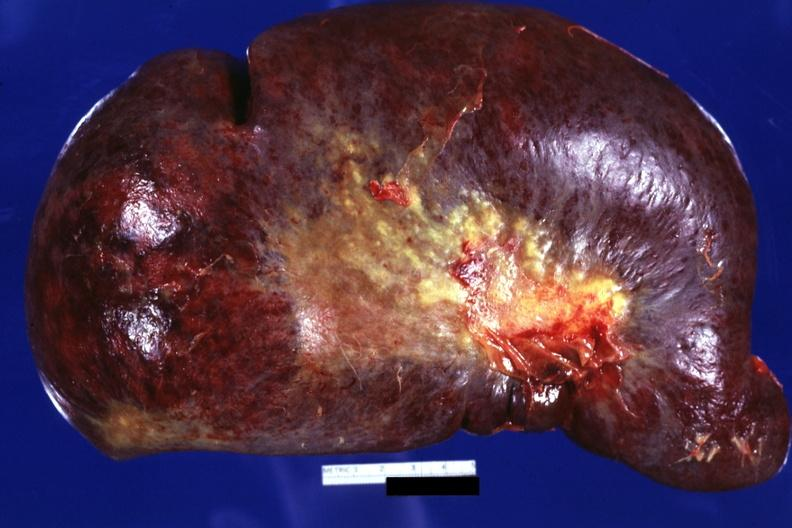s splenomegaly with cirrhosis present?
Answer the question using a single word or phrase. Yes 